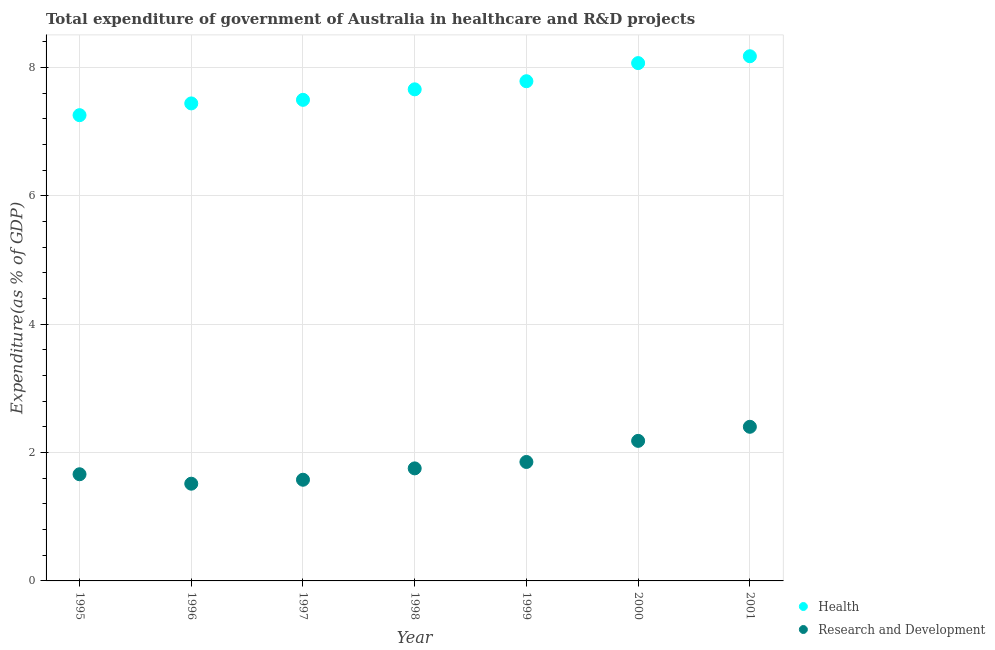What is the expenditure in healthcare in 2000?
Keep it short and to the point. 8.07. Across all years, what is the maximum expenditure in r&d?
Keep it short and to the point. 2.4. Across all years, what is the minimum expenditure in healthcare?
Your answer should be compact. 7.26. In which year was the expenditure in r&d maximum?
Provide a succinct answer. 2001. In which year was the expenditure in healthcare minimum?
Offer a very short reply. 1995. What is the total expenditure in healthcare in the graph?
Offer a terse response. 53.88. What is the difference between the expenditure in healthcare in 1997 and that in 2000?
Your response must be concise. -0.57. What is the difference between the expenditure in r&d in 1999 and the expenditure in healthcare in 2000?
Provide a succinct answer. -6.21. What is the average expenditure in healthcare per year?
Provide a short and direct response. 7.7. In the year 1999, what is the difference between the expenditure in r&d and expenditure in healthcare?
Ensure brevity in your answer.  -5.93. In how many years, is the expenditure in healthcare greater than 1.2000000000000002 %?
Make the answer very short. 7. What is the ratio of the expenditure in healthcare in 1995 to that in 1999?
Your answer should be very brief. 0.93. What is the difference between the highest and the second highest expenditure in healthcare?
Keep it short and to the point. 0.11. What is the difference between the highest and the lowest expenditure in r&d?
Your answer should be compact. 0.89. Is the sum of the expenditure in r&d in 1995 and 2000 greater than the maximum expenditure in healthcare across all years?
Keep it short and to the point. No. Is the expenditure in healthcare strictly less than the expenditure in r&d over the years?
Offer a very short reply. No. How many dotlines are there?
Keep it short and to the point. 2. How many years are there in the graph?
Make the answer very short. 7. Are the values on the major ticks of Y-axis written in scientific E-notation?
Make the answer very short. No. Does the graph contain any zero values?
Ensure brevity in your answer.  No. Does the graph contain grids?
Keep it short and to the point. Yes. Where does the legend appear in the graph?
Make the answer very short. Bottom right. How many legend labels are there?
Keep it short and to the point. 2. How are the legend labels stacked?
Offer a terse response. Vertical. What is the title of the graph?
Make the answer very short. Total expenditure of government of Australia in healthcare and R&D projects. Does "Unregistered firms" appear as one of the legend labels in the graph?
Your answer should be compact. No. What is the label or title of the X-axis?
Your response must be concise. Year. What is the label or title of the Y-axis?
Give a very brief answer. Expenditure(as % of GDP). What is the Expenditure(as % of GDP) in Health in 1995?
Your answer should be very brief. 7.26. What is the Expenditure(as % of GDP) in Research and Development in 1995?
Keep it short and to the point. 1.66. What is the Expenditure(as % of GDP) of Health in 1996?
Keep it short and to the point. 7.44. What is the Expenditure(as % of GDP) of Research and Development in 1996?
Your response must be concise. 1.51. What is the Expenditure(as % of GDP) of Health in 1997?
Ensure brevity in your answer.  7.5. What is the Expenditure(as % of GDP) in Research and Development in 1997?
Make the answer very short. 1.58. What is the Expenditure(as % of GDP) in Health in 1998?
Provide a short and direct response. 7.66. What is the Expenditure(as % of GDP) in Research and Development in 1998?
Ensure brevity in your answer.  1.75. What is the Expenditure(as % of GDP) in Health in 1999?
Your answer should be very brief. 7.79. What is the Expenditure(as % of GDP) of Research and Development in 1999?
Offer a very short reply. 1.85. What is the Expenditure(as % of GDP) of Health in 2000?
Give a very brief answer. 8.07. What is the Expenditure(as % of GDP) in Research and Development in 2000?
Offer a terse response. 2.18. What is the Expenditure(as % of GDP) of Health in 2001?
Your answer should be very brief. 8.17. What is the Expenditure(as % of GDP) of Research and Development in 2001?
Your answer should be very brief. 2.4. Across all years, what is the maximum Expenditure(as % of GDP) of Health?
Provide a succinct answer. 8.17. Across all years, what is the maximum Expenditure(as % of GDP) of Research and Development?
Your answer should be compact. 2.4. Across all years, what is the minimum Expenditure(as % of GDP) of Health?
Provide a succinct answer. 7.26. Across all years, what is the minimum Expenditure(as % of GDP) in Research and Development?
Provide a short and direct response. 1.51. What is the total Expenditure(as % of GDP) in Health in the graph?
Your answer should be compact. 53.88. What is the total Expenditure(as % of GDP) in Research and Development in the graph?
Your answer should be very brief. 12.94. What is the difference between the Expenditure(as % of GDP) in Health in 1995 and that in 1996?
Provide a succinct answer. -0.18. What is the difference between the Expenditure(as % of GDP) in Research and Development in 1995 and that in 1996?
Your response must be concise. 0.15. What is the difference between the Expenditure(as % of GDP) of Health in 1995 and that in 1997?
Your response must be concise. -0.24. What is the difference between the Expenditure(as % of GDP) in Research and Development in 1995 and that in 1997?
Provide a succinct answer. 0.09. What is the difference between the Expenditure(as % of GDP) of Health in 1995 and that in 1998?
Provide a short and direct response. -0.4. What is the difference between the Expenditure(as % of GDP) in Research and Development in 1995 and that in 1998?
Your answer should be compact. -0.09. What is the difference between the Expenditure(as % of GDP) in Health in 1995 and that in 1999?
Your answer should be very brief. -0.53. What is the difference between the Expenditure(as % of GDP) in Research and Development in 1995 and that in 1999?
Ensure brevity in your answer.  -0.19. What is the difference between the Expenditure(as % of GDP) of Health in 1995 and that in 2000?
Provide a short and direct response. -0.81. What is the difference between the Expenditure(as % of GDP) in Research and Development in 1995 and that in 2000?
Provide a short and direct response. -0.52. What is the difference between the Expenditure(as % of GDP) in Health in 1995 and that in 2001?
Provide a short and direct response. -0.92. What is the difference between the Expenditure(as % of GDP) in Research and Development in 1995 and that in 2001?
Give a very brief answer. -0.74. What is the difference between the Expenditure(as % of GDP) of Health in 1996 and that in 1997?
Give a very brief answer. -0.06. What is the difference between the Expenditure(as % of GDP) of Research and Development in 1996 and that in 1997?
Give a very brief answer. -0.06. What is the difference between the Expenditure(as % of GDP) of Health in 1996 and that in 1998?
Make the answer very short. -0.22. What is the difference between the Expenditure(as % of GDP) of Research and Development in 1996 and that in 1998?
Ensure brevity in your answer.  -0.24. What is the difference between the Expenditure(as % of GDP) of Health in 1996 and that in 1999?
Provide a succinct answer. -0.35. What is the difference between the Expenditure(as % of GDP) of Research and Development in 1996 and that in 1999?
Offer a terse response. -0.34. What is the difference between the Expenditure(as % of GDP) in Health in 1996 and that in 2000?
Your answer should be very brief. -0.63. What is the difference between the Expenditure(as % of GDP) in Research and Development in 1996 and that in 2000?
Keep it short and to the point. -0.67. What is the difference between the Expenditure(as % of GDP) of Health in 1996 and that in 2001?
Your response must be concise. -0.73. What is the difference between the Expenditure(as % of GDP) in Research and Development in 1996 and that in 2001?
Keep it short and to the point. -0.89. What is the difference between the Expenditure(as % of GDP) in Health in 1997 and that in 1998?
Ensure brevity in your answer.  -0.16. What is the difference between the Expenditure(as % of GDP) of Research and Development in 1997 and that in 1998?
Give a very brief answer. -0.18. What is the difference between the Expenditure(as % of GDP) of Health in 1997 and that in 1999?
Your answer should be compact. -0.29. What is the difference between the Expenditure(as % of GDP) of Research and Development in 1997 and that in 1999?
Your answer should be very brief. -0.28. What is the difference between the Expenditure(as % of GDP) of Health in 1997 and that in 2000?
Provide a succinct answer. -0.57. What is the difference between the Expenditure(as % of GDP) in Research and Development in 1997 and that in 2000?
Your response must be concise. -0.61. What is the difference between the Expenditure(as % of GDP) of Health in 1997 and that in 2001?
Your answer should be compact. -0.68. What is the difference between the Expenditure(as % of GDP) in Research and Development in 1997 and that in 2001?
Give a very brief answer. -0.82. What is the difference between the Expenditure(as % of GDP) of Health in 1998 and that in 1999?
Make the answer very short. -0.13. What is the difference between the Expenditure(as % of GDP) of Health in 1998 and that in 2000?
Ensure brevity in your answer.  -0.41. What is the difference between the Expenditure(as % of GDP) of Research and Development in 1998 and that in 2000?
Provide a short and direct response. -0.43. What is the difference between the Expenditure(as % of GDP) in Health in 1998 and that in 2001?
Offer a terse response. -0.52. What is the difference between the Expenditure(as % of GDP) in Research and Development in 1998 and that in 2001?
Ensure brevity in your answer.  -0.65. What is the difference between the Expenditure(as % of GDP) of Health in 1999 and that in 2000?
Ensure brevity in your answer.  -0.28. What is the difference between the Expenditure(as % of GDP) in Research and Development in 1999 and that in 2000?
Your answer should be compact. -0.33. What is the difference between the Expenditure(as % of GDP) in Health in 1999 and that in 2001?
Give a very brief answer. -0.39. What is the difference between the Expenditure(as % of GDP) in Research and Development in 1999 and that in 2001?
Provide a succinct answer. -0.55. What is the difference between the Expenditure(as % of GDP) of Health in 2000 and that in 2001?
Give a very brief answer. -0.11. What is the difference between the Expenditure(as % of GDP) of Research and Development in 2000 and that in 2001?
Ensure brevity in your answer.  -0.22. What is the difference between the Expenditure(as % of GDP) in Health in 1995 and the Expenditure(as % of GDP) in Research and Development in 1996?
Your answer should be very brief. 5.74. What is the difference between the Expenditure(as % of GDP) of Health in 1995 and the Expenditure(as % of GDP) of Research and Development in 1997?
Your answer should be very brief. 5.68. What is the difference between the Expenditure(as % of GDP) of Health in 1995 and the Expenditure(as % of GDP) of Research and Development in 1998?
Make the answer very short. 5.5. What is the difference between the Expenditure(as % of GDP) in Health in 1995 and the Expenditure(as % of GDP) in Research and Development in 1999?
Your response must be concise. 5.4. What is the difference between the Expenditure(as % of GDP) of Health in 1995 and the Expenditure(as % of GDP) of Research and Development in 2000?
Ensure brevity in your answer.  5.07. What is the difference between the Expenditure(as % of GDP) in Health in 1995 and the Expenditure(as % of GDP) in Research and Development in 2001?
Offer a terse response. 4.86. What is the difference between the Expenditure(as % of GDP) of Health in 1996 and the Expenditure(as % of GDP) of Research and Development in 1997?
Keep it short and to the point. 5.86. What is the difference between the Expenditure(as % of GDP) in Health in 1996 and the Expenditure(as % of GDP) in Research and Development in 1998?
Keep it short and to the point. 5.69. What is the difference between the Expenditure(as % of GDP) of Health in 1996 and the Expenditure(as % of GDP) of Research and Development in 1999?
Your response must be concise. 5.59. What is the difference between the Expenditure(as % of GDP) of Health in 1996 and the Expenditure(as % of GDP) of Research and Development in 2000?
Your answer should be very brief. 5.26. What is the difference between the Expenditure(as % of GDP) in Health in 1996 and the Expenditure(as % of GDP) in Research and Development in 2001?
Keep it short and to the point. 5.04. What is the difference between the Expenditure(as % of GDP) in Health in 1997 and the Expenditure(as % of GDP) in Research and Development in 1998?
Your answer should be compact. 5.74. What is the difference between the Expenditure(as % of GDP) of Health in 1997 and the Expenditure(as % of GDP) of Research and Development in 1999?
Ensure brevity in your answer.  5.64. What is the difference between the Expenditure(as % of GDP) in Health in 1997 and the Expenditure(as % of GDP) in Research and Development in 2000?
Provide a short and direct response. 5.31. What is the difference between the Expenditure(as % of GDP) of Health in 1997 and the Expenditure(as % of GDP) of Research and Development in 2001?
Offer a very short reply. 5.09. What is the difference between the Expenditure(as % of GDP) in Health in 1998 and the Expenditure(as % of GDP) in Research and Development in 1999?
Offer a very short reply. 5.81. What is the difference between the Expenditure(as % of GDP) in Health in 1998 and the Expenditure(as % of GDP) in Research and Development in 2000?
Offer a very short reply. 5.48. What is the difference between the Expenditure(as % of GDP) in Health in 1998 and the Expenditure(as % of GDP) in Research and Development in 2001?
Offer a terse response. 5.26. What is the difference between the Expenditure(as % of GDP) in Health in 1999 and the Expenditure(as % of GDP) in Research and Development in 2000?
Give a very brief answer. 5.6. What is the difference between the Expenditure(as % of GDP) of Health in 1999 and the Expenditure(as % of GDP) of Research and Development in 2001?
Keep it short and to the point. 5.38. What is the difference between the Expenditure(as % of GDP) of Health in 2000 and the Expenditure(as % of GDP) of Research and Development in 2001?
Provide a succinct answer. 5.67. What is the average Expenditure(as % of GDP) in Health per year?
Provide a short and direct response. 7.7. What is the average Expenditure(as % of GDP) of Research and Development per year?
Ensure brevity in your answer.  1.85. In the year 1995, what is the difference between the Expenditure(as % of GDP) in Health and Expenditure(as % of GDP) in Research and Development?
Provide a succinct answer. 5.59. In the year 1996, what is the difference between the Expenditure(as % of GDP) of Health and Expenditure(as % of GDP) of Research and Development?
Your response must be concise. 5.92. In the year 1997, what is the difference between the Expenditure(as % of GDP) in Health and Expenditure(as % of GDP) in Research and Development?
Your response must be concise. 5.92. In the year 1998, what is the difference between the Expenditure(as % of GDP) of Health and Expenditure(as % of GDP) of Research and Development?
Your response must be concise. 5.91. In the year 1999, what is the difference between the Expenditure(as % of GDP) in Health and Expenditure(as % of GDP) in Research and Development?
Your answer should be compact. 5.93. In the year 2000, what is the difference between the Expenditure(as % of GDP) in Health and Expenditure(as % of GDP) in Research and Development?
Offer a terse response. 5.89. In the year 2001, what is the difference between the Expenditure(as % of GDP) of Health and Expenditure(as % of GDP) of Research and Development?
Your response must be concise. 5.77. What is the ratio of the Expenditure(as % of GDP) of Health in 1995 to that in 1996?
Offer a terse response. 0.98. What is the ratio of the Expenditure(as % of GDP) in Research and Development in 1995 to that in 1996?
Provide a succinct answer. 1.1. What is the ratio of the Expenditure(as % of GDP) of Health in 1995 to that in 1997?
Your answer should be very brief. 0.97. What is the ratio of the Expenditure(as % of GDP) of Research and Development in 1995 to that in 1997?
Keep it short and to the point. 1.05. What is the ratio of the Expenditure(as % of GDP) of Research and Development in 1995 to that in 1998?
Give a very brief answer. 0.95. What is the ratio of the Expenditure(as % of GDP) in Health in 1995 to that in 1999?
Provide a succinct answer. 0.93. What is the ratio of the Expenditure(as % of GDP) in Research and Development in 1995 to that in 1999?
Offer a very short reply. 0.9. What is the ratio of the Expenditure(as % of GDP) of Health in 1995 to that in 2000?
Keep it short and to the point. 0.9. What is the ratio of the Expenditure(as % of GDP) in Research and Development in 1995 to that in 2000?
Provide a succinct answer. 0.76. What is the ratio of the Expenditure(as % of GDP) in Health in 1995 to that in 2001?
Ensure brevity in your answer.  0.89. What is the ratio of the Expenditure(as % of GDP) in Research and Development in 1995 to that in 2001?
Provide a short and direct response. 0.69. What is the ratio of the Expenditure(as % of GDP) in Health in 1996 to that in 1997?
Offer a terse response. 0.99. What is the ratio of the Expenditure(as % of GDP) in Research and Development in 1996 to that in 1997?
Your answer should be compact. 0.96. What is the ratio of the Expenditure(as % of GDP) of Health in 1996 to that in 1998?
Offer a terse response. 0.97. What is the ratio of the Expenditure(as % of GDP) of Research and Development in 1996 to that in 1998?
Keep it short and to the point. 0.86. What is the ratio of the Expenditure(as % of GDP) of Health in 1996 to that in 1999?
Ensure brevity in your answer.  0.96. What is the ratio of the Expenditure(as % of GDP) of Research and Development in 1996 to that in 1999?
Offer a terse response. 0.82. What is the ratio of the Expenditure(as % of GDP) in Health in 1996 to that in 2000?
Your answer should be compact. 0.92. What is the ratio of the Expenditure(as % of GDP) in Research and Development in 1996 to that in 2000?
Offer a terse response. 0.69. What is the ratio of the Expenditure(as % of GDP) in Health in 1996 to that in 2001?
Your answer should be very brief. 0.91. What is the ratio of the Expenditure(as % of GDP) in Research and Development in 1996 to that in 2001?
Your answer should be compact. 0.63. What is the ratio of the Expenditure(as % of GDP) of Health in 1997 to that in 1998?
Your answer should be compact. 0.98. What is the ratio of the Expenditure(as % of GDP) of Research and Development in 1997 to that in 1998?
Offer a very short reply. 0.9. What is the ratio of the Expenditure(as % of GDP) in Health in 1997 to that in 1999?
Offer a very short reply. 0.96. What is the ratio of the Expenditure(as % of GDP) in Research and Development in 1997 to that in 1999?
Give a very brief answer. 0.85. What is the ratio of the Expenditure(as % of GDP) of Health in 1997 to that in 2000?
Your answer should be very brief. 0.93. What is the ratio of the Expenditure(as % of GDP) in Research and Development in 1997 to that in 2000?
Provide a succinct answer. 0.72. What is the ratio of the Expenditure(as % of GDP) in Health in 1997 to that in 2001?
Ensure brevity in your answer.  0.92. What is the ratio of the Expenditure(as % of GDP) in Research and Development in 1997 to that in 2001?
Make the answer very short. 0.66. What is the ratio of the Expenditure(as % of GDP) in Health in 1998 to that in 1999?
Give a very brief answer. 0.98. What is the ratio of the Expenditure(as % of GDP) in Research and Development in 1998 to that in 1999?
Offer a very short reply. 0.95. What is the ratio of the Expenditure(as % of GDP) of Health in 1998 to that in 2000?
Your answer should be very brief. 0.95. What is the ratio of the Expenditure(as % of GDP) in Research and Development in 1998 to that in 2000?
Your answer should be compact. 0.8. What is the ratio of the Expenditure(as % of GDP) in Health in 1998 to that in 2001?
Make the answer very short. 0.94. What is the ratio of the Expenditure(as % of GDP) of Research and Development in 1998 to that in 2001?
Your response must be concise. 0.73. What is the ratio of the Expenditure(as % of GDP) of Research and Development in 1999 to that in 2000?
Give a very brief answer. 0.85. What is the ratio of the Expenditure(as % of GDP) of Research and Development in 1999 to that in 2001?
Make the answer very short. 0.77. What is the ratio of the Expenditure(as % of GDP) in Health in 2000 to that in 2001?
Offer a terse response. 0.99. What is the ratio of the Expenditure(as % of GDP) of Research and Development in 2000 to that in 2001?
Your answer should be compact. 0.91. What is the difference between the highest and the second highest Expenditure(as % of GDP) of Health?
Your answer should be compact. 0.11. What is the difference between the highest and the second highest Expenditure(as % of GDP) in Research and Development?
Give a very brief answer. 0.22. What is the difference between the highest and the lowest Expenditure(as % of GDP) of Health?
Give a very brief answer. 0.92. What is the difference between the highest and the lowest Expenditure(as % of GDP) in Research and Development?
Make the answer very short. 0.89. 